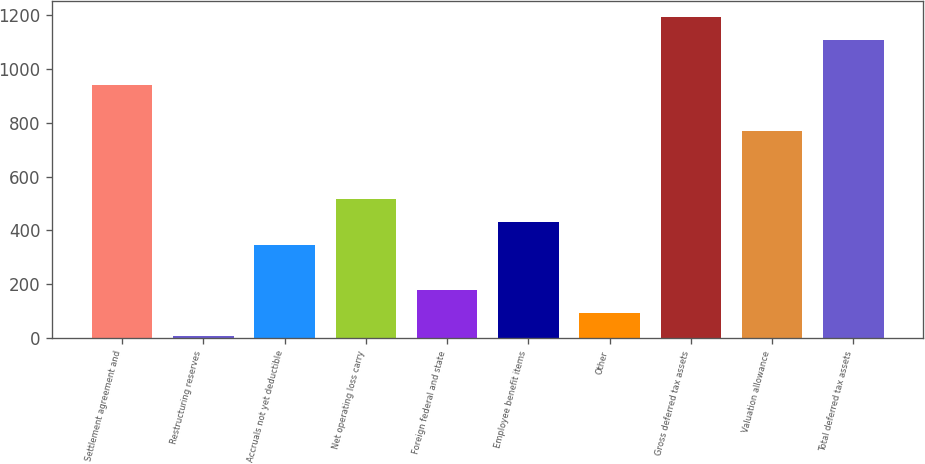Convert chart. <chart><loc_0><loc_0><loc_500><loc_500><bar_chart><fcel>Settlement agreement and<fcel>Restructuring reserves<fcel>Accruals not yet deductible<fcel>Net operating loss carry<fcel>Foreign federal and state<fcel>Employee benefit items<fcel>Other<fcel>Gross deferred tax assets<fcel>Valuation allowance<fcel>Total deferred tax assets<nl><fcel>938.31<fcel>8.7<fcel>346.74<fcel>515.76<fcel>177.72<fcel>431.25<fcel>93.21<fcel>1191.84<fcel>769.29<fcel>1107.33<nl></chart> 